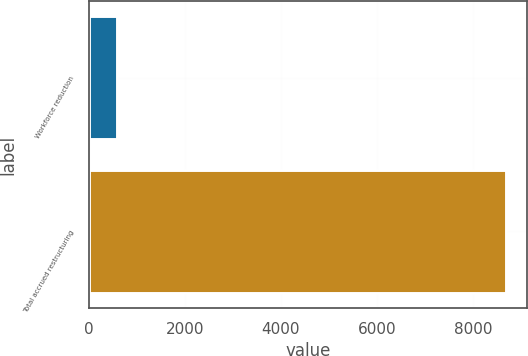Convert chart. <chart><loc_0><loc_0><loc_500><loc_500><bar_chart><fcel>Workforce reduction<fcel>Total accrued restructuring<nl><fcel>582<fcel>8685<nl></chart> 